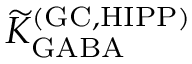<formula> <loc_0><loc_0><loc_500><loc_500>{ \widetilde { K } } _ { G A B A } ^ { ( G C , H I P P ) }</formula> 